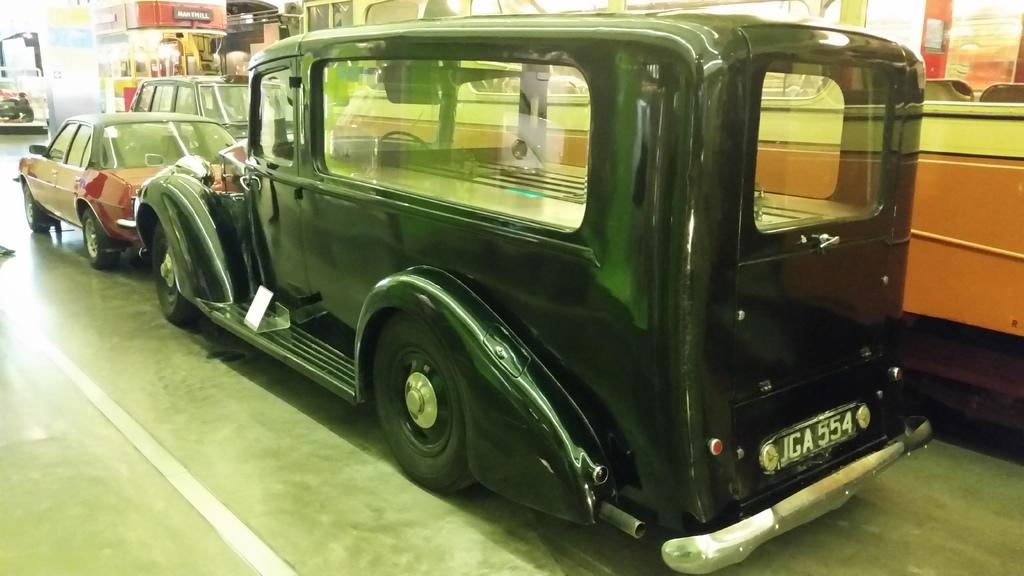What types of vehicles can be seen in the image? There are different kinds of vehicles in the image. What is located in the background of the image? There is a pillar with posters in the background. Can you describe any other elements in the background? There are other unspecified elements in the background. What type of linen is draped over the vehicles in the image? There is no linen draped over the vehicles in the image. How many silver coins can be seen on the ground near the vehicles? There are no silver coins visible on the ground near the vehicles in the image. 